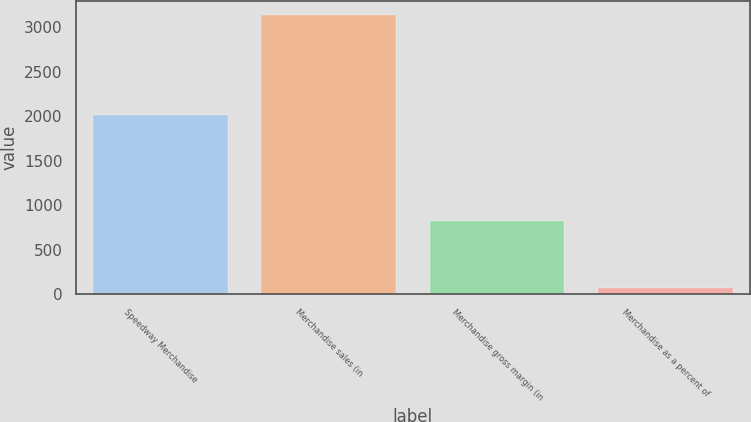<chart> <loc_0><loc_0><loc_500><loc_500><bar_chart><fcel>Speedway Merchandise<fcel>Merchandise sales (in<fcel>Merchandise gross margin (in<fcel>Merchandise as a percent of<nl><fcel>2013<fcel>3135<fcel>825<fcel>65<nl></chart> 